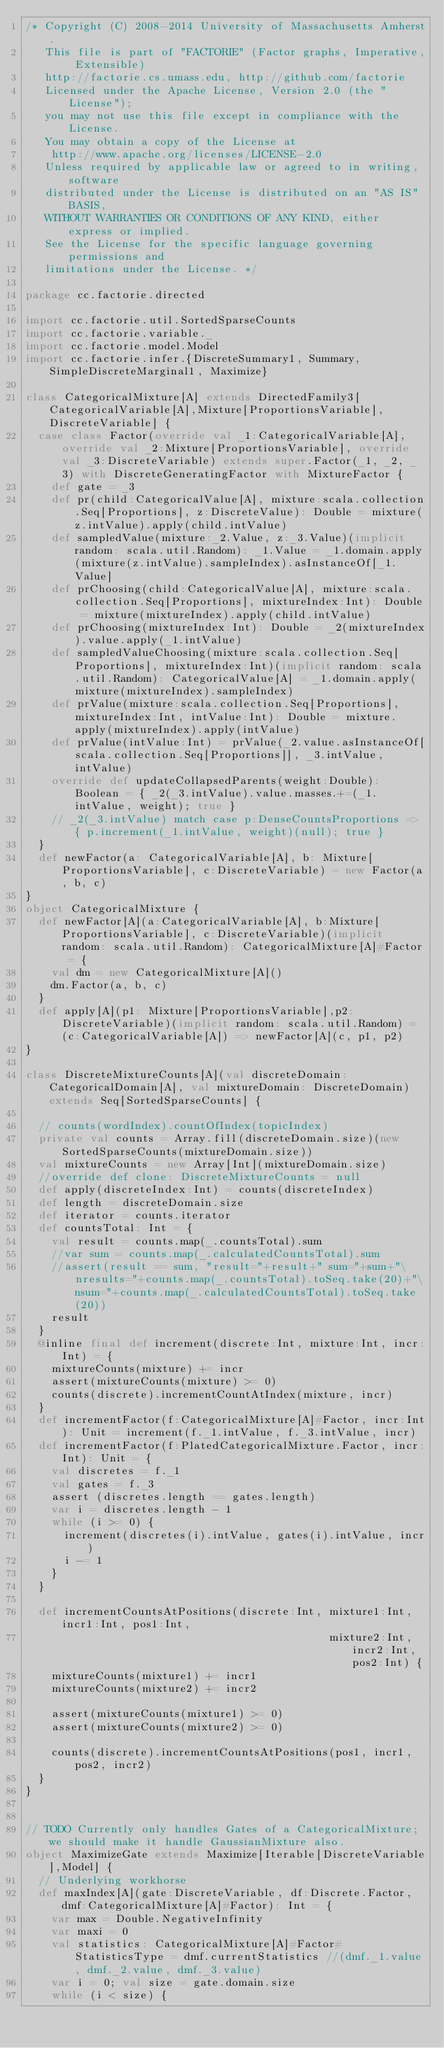Convert code to text. <code><loc_0><loc_0><loc_500><loc_500><_Scala_>/* Copyright (C) 2008-2014 University of Massachusetts Amherst.
   This file is part of "FACTORIE" (Factor graphs, Imperative, Extensible)
   http://factorie.cs.umass.edu, http://github.com/factorie
   Licensed under the Apache License, Version 2.0 (the "License");
   you may not use this file except in compliance with the License.
   You may obtain a copy of the License at
    http://www.apache.org/licenses/LICENSE-2.0
   Unless required by applicable law or agreed to in writing, software
   distributed under the License is distributed on an "AS IS" BASIS,
   WITHOUT WARRANTIES OR CONDITIONS OF ANY KIND, either express or implied.
   See the License for the specific language governing permissions and
   limitations under the License. */

package cc.factorie.directed

import cc.factorie.util.SortedSparseCounts
import cc.factorie.variable._
import cc.factorie.model.Model
import cc.factorie.infer.{DiscreteSummary1, Summary, SimpleDiscreteMarginal1, Maximize}

class CategoricalMixture[A] extends DirectedFamily3[CategoricalVariable[A],Mixture[ProportionsVariable],DiscreteVariable] {
  case class Factor(override val _1:CategoricalVariable[A], override val _2:Mixture[ProportionsVariable], override val _3:DiscreteVariable) extends super.Factor(_1, _2, _3) with DiscreteGeneratingFactor with MixtureFactor {
    def gate = _3
    def pr(child:CategoricalValue[A], mixture:scala.collection.Seq[Proportions], z:DiscreteValue): Double = mixture(z.intValue).apply(child.intValue)
    def sampledValue(mixture:_2.Value, z:_3.Value)(implicit random: scala.util.Random): _1.Value = _1.domain.apply(mixture(z.intValue).sampleIndex).asInstanceOf[_1.Value]
    def prChoosing(child:CategoricalValue[A], mixture:scala.collection.Seq[Proportions], mixtureIndex:Int): Double = mixture(mixtureIndex).apply(child.intValue)
    def prChoosing(mixtureIndex:Int): Double = _2(mixtureIndex).value.apply(_1.intValue)
    def sampledValueChoosing(mixture:scala.collection.Seq[Proportions], mixtureIndex:Int)(implicit random: scala.util.Random): CategoricalValue[A] = _1.domain.apply(mixture(mixtureIndex).sampleIndex)
    def prValue(mixture:scala.collection.Seq[Proportions], mixtureIndex:Int, intValue:Int): Double = mixture.apply(mixtureIndex).apply(intValue)
    def prValue(intValue:Int) = prValue(_2.value.asInstanceOf[scala.collection.Seq[Proportions]], _3.intValue, intValue)
    override def updateCollapsedParents(weight:Double): Boolean = { _2(_3.intValue).value.masses.+=(_1.intValue, weight); true }
    // _2(_3.intValue) match case p:DenseCountsProportions => { p.increment(_1.intValue, weight)(null); true }
  }
  def newFactor(a: CategoricalVariable[A], b: Mixture[ProportionsVariable], c:DiscreteVariable) = new Factor(a, b, c)
}
object CategoricalMixture {
  def newFactor[A](a:CategoricalVariable[A], b:Mixture[ProportionsVariable], c:DiscreteVariable)(implicit random: scala.util.Random): CategoricalMixture[A]#Factor = {
    val dm = new CategoricalMixture[A]()
    dm.Factor(a, b, c)
  }
  def apply[A](p1: Mixture[ProportionsVariable],p2:DiscreteVariable)(implicit random: scala.util.Random) = (c:CategoricalVariable[A]) => newFactor[A](c, p1, p2)
}

class DiscreteMixtureCounts[A](val discreteDomain: CategoricalDomain[A], val mixtureDomain: DiscreteDomain) extends Seq[SortedSparseCounts] {

  // counts(wordIndex).countOfIndex(topicIndex)
  private val counts = Array.fill(discreteDomain.size)(new SortedSparseCounts(mixtureDomain.size))
  val mixtureCounts = new Array[Int](mixtureDomain.size)
  //override def clone: DiscreteMixtureCounts = null
  def apply(discreteIndex:Int) = counts(discreteIndex)
  def length = discreteDomain.size
  def iterator = counts.iterator
  def countsTotal: Int = {
    val result = counts.map(_.countsTotal).sum
    //var sum = counts.map(_.calculatedCountsTotal).sum
    //assert(result == sum, "result="+result+" sum="+sum+"\nresults="+counts.map(_.countsTotal).toSeq.take(20)+"\nsum="+counts.map(_.calculatedCountsTotal).toSeq.take(20))
    result
  }
  @inline final def increment(discrete:Int, mixture:Int, incr:Int) = {
    mixtureCounts(mixture) += incr
    assert(mixtureCounts(mixture) >= 0)
    counts(discrete).incrementCountAtIndex(mixture, incr)
  }
  def incrementFactor(f:CategoricalMixture[A]#Factor, incr:Int): Unit = increment(f._1.intValue, f._3.intValue, incr)
  def incrementFactor(f:PlatedCategoricalMixture.Factor, incr:Int): Unit = {
    val discretes = f._1
    val gates = f._3
    assert (discretes.length == gates.length)
    var i = discretes.length - 1
    while (i >= 0) {
      increment(discretes(i).intValue, gates(i).intValue, incr)
      i -= 1
    }
  }

  def incrementCountsAtPositions(discrete:Int, mixture1:Int, incr1:Int, pos1:Int,
                                               mixture2:Int, incr2:Int, pos2:Int) {
    mixtureCounts(mixture1) += incr1
    mixtureCounts(mixture2) += incr2

    assert(mixtureCounts(mixture1) >= 0)
    assert(mixtureCounts(mixture2) >= 0)

    counts(discrete).incrementCountsAtPositions(pos1, incr1, pos2, incr2)
  }
}


// TODO Currently only handles Gates of a CategoricalMixture; we should make it handle GaussianMixture also.
object MaximizeGate extends Maximize[Iterable[DiscreteVariable],Model] {
  // Underlying workhorse
  def maxIndex[A](gate:DiscreteVariable, df:Discrete.Factor, dmf:CategoricalMixture[A]#Factor): Int = {
    var max = Double.NegativeInfinity
    var maxi = 0
    val statistics: CategoricalMixture[A]#Factor#StatisticsType = dmf.currentStatistics //(dmf._1.value, dmf._2.value, dmf._3.value)
    var i = 0; val size = gate.domain.size
    while (i < size) {</code> 